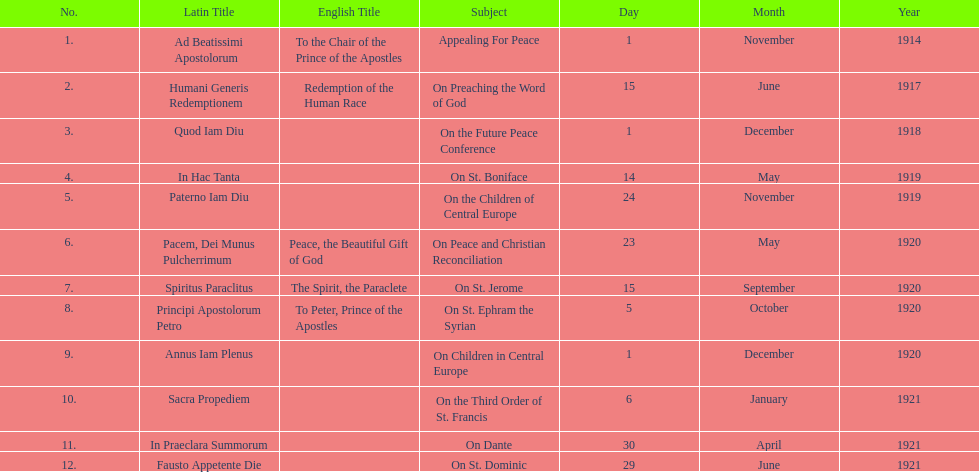How many titles are listed in the table? 12. 